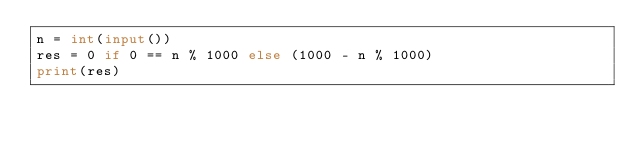<code> <loc_0><loc_0><loc_500><loc_500><_Python_>n = int(input())
res = 0 if 0 == n % 1000 else (1000 - n % 1000)
print(res)
</code> 